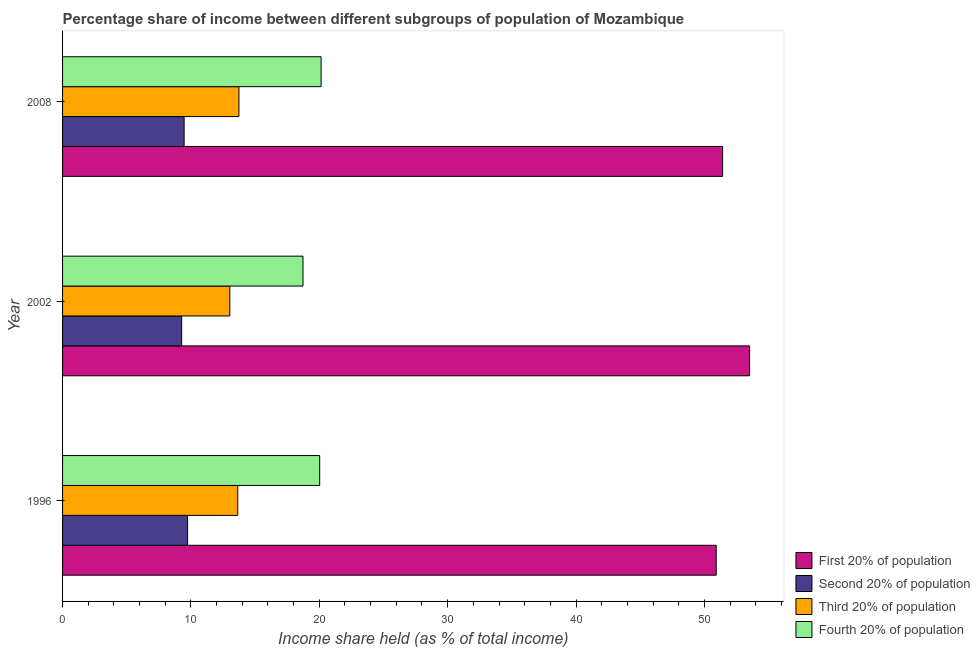How many different coloured bars are there?
Your response must be concise. 4. Are the number of bars per tick equal to the number of legend labels?
Make the answer very short. Yes. Are the number of bars on each tick of the Y-axis equal?
Offer a very short reply. Yes. How many bars are there on the 1st tick from the bottom?
Give a very brief answer. 4. What is the share of the income held by first 20% of the population in 1996?
Your answer should be very brief. 50.92. Across all years, what is the maximum share of the income held by first 20% of the population?
Offer a very short reply. 53.52. Across all years, what is the minimum share of the income held by second 20% of the population?
Ensure brevity in your answer.  9.28. In which year was the share of the income held by third 20% of the population maximum?
Give a very brief answer. 2008. What is the total share of the income held by first 20% of the population in the graph?
Your answer should be very brief. 155.86. What is the difference between the share of the income held by first 20% of the population in 2002 and that in 2008?
Ensure brevity in your answer.  2.1. What is the difference between the share of the income held by first 20% of the population in 1996 and the share of the income held by fourth 20% of the population in 2002?
Provide a short and direct response. 32.19. What is the average share of the income held by second 20% of the population per year?
Your answer should be very brief. 9.5. In the year 2002, what is the difference between the share of the income held by second 20% of the population and share of the income held by third 20% of the population?
Your response must be concise. -3.75. In how many years, is the share of the income held by second 20% of the population greater than 28 %?
Your response must be concise. 0. What is the difference between the highest and the second highest share of the income held by second 20% of the population?
Provide a short and direct response. 0.27. What is the difference between the highest and the lowest share of the income held by second 20% of the population?
Your answer should be very brief. 0.46. Is it the case that in every year, the sum of the share of the income held by fourth 20% of the population and share of the income held by second 20% of the population is greater than the sum of share of the income held by first 20% of the population and share of the income held by third 20% of the population?
Your answer should be very brief. Yes. What does the 4th bar from the top in 1996 represents?
Provide a succinct answer. First 20% of population. What does the 2nd bar from the bottom in 1996 represents?
Give a very brief answer. Second 20% of population. How many years are there in the graph?
Your response must be concise. 3. Are the values on the major ticks of X-axis written in scientific E-notation?
Ensure brevity in your answer.  No. Does the graph contain any zero values?
Provide a succinct answer. No. Does the graph contain grids?
Your response must be concise. No. What is the title of the graph?
Your answer should be compact. Percentage share of income between different subgroups of population of Mozambique. What is the label or title of the X-axis?
Keep it short and to the point. Income share held (as % of total income). What is the label or title of the Y-axis?
Your response must be concise. Year. What is the Income share held (as % of total income) in First 20% of population in 1996?
Offer a terse response. 50.92. What is the Income share held (as % of total income) in Second 20% of population in 1996?
Your answer should be very brief. 9.74. What is the Income share held (as % of total income) in Third 20% of population in 1996?
Your response must be concise. 13.65. What is the Income share held (as % of total income) of Fourth 20% of population in 1996?
Make the answer very short. 20.03. What is the Income share held (as % of total income) in First 20% of population in 2002?
Your answer should be compact. 53.52. What is the Income share held (as % of total income) of Second 20% of population in 2002?
Make the answer very short. 9.28. What is the Income share held (as % of total income) in Third 20% of population in 2002?
Your answer should be compact. 13.03. What is the Income share held (as % of total income) in Fourth 20% of population in 2002?
Offer a very short reply. 18.73. What is the Income share held (as % of total income) of First 20% of population in 2008?
Provide a succinct answer. 51.42. What is the Income share held (as % of total income) in Second 20% of population in 2008?
Give a very brief answer. 9.47. What is the Income share held (as % of total income) in Third 20% of population in 2008?
Your answer should be very brief. 13.74. What is the Income share held (as % of total income) of Fourth 20% of population in 2008?
Offer a very short reply. 20.14. Across all years, what is the maximum Income share held (as % of total income) in First 20% of population?
Offer a terse response. 53.52. Across all years, what is the maximum Income share held (as % of total income) in Second 20% of population?
Your answer should be compact. 9.74. Across all years, what is the maximum Income share held (as % of total income) of Third 20% of population?
Give a very brief answer. 13.74. Across all years, what is the maximum Income share held (as % of total income) in Fourth 20% of population?
Provide a succinct answer. 20.14. Across all years, what is the minimum Income share held (as % of total income) of First 20% of population?
Offer a terse response. 50.92. Across all years, what is the minimum Income share held (as % of total income) of Second 20% of population?
Your answer should be compact. 9.28. Across all years, what is the minimum Income share held (as % of total income) in Third 20% of population?
Give a very brief answer. 13.03. Across all years, what is the minimum Income share held (as % of total income) in Fourth 20% of population?
Make the answer very short. 18.73. What is the total Income share held (as % of total income) of First 20% of population in the graph?
Your response must be concise. 155.86. What is the total Income share held (as % of total income) in Second 20% of population in the graph?
Provide a succinct answer. 28.49. What is the total Income share held (as % of total income) in Third 20% of population in the graph?
Keep it short and to the point. 40.42. What is the total Income share held (as % of total income) in Fourth 20% of population in the graph?
Your response must be concise. 58.9. What is the difference between the Income share held (as % of total income) of Second 20% of population in 1996 and that in 2002?
Keep it short and to the point. 0.46. What is the difference between the Income share held (as % of total income) in Third 20% of population in 1996 and that in 2002?
Offer a terse response. 0.62. What is the difference between the Income share held (as % of total income) of Fourth 20% of population in 1996 and that in 2002?
Make the answer very short. 1.3. What is the difference between the Income share held (as % of total income) of First 20% of population in 1996 and that in 2008?
Provide a short and direct response. -0.5. What is the difference between the Income share held (as % of total income) in Second 20% of population in 1996 and that in 2008?
Offer a terse response. 0.27. What is the difference between the Income share held (as % of total income) of Third 20% of population in 1996 and that in 2008?
Ensure brevity in your answer.  -0.09. What is the difference between the Income share held (as % of total income) in Fourth 20% of population in 1996 and that in 2008?
Offer a very short reply. -0.11. What is the difference between the Income share held (as % of total income) in Second 20% of population in 2002 and that in 2008?
Provide a short and direct response. -0.19. What is the difference between the Income share held (as % of total income) of Third 20% of population in 2002 and that in 2008?
Your answer should be very brief. -0.71. What is the difference between the Income share held (as % of total income) in Fourth 20% of population in 2002 and that in 2008?
Give a very brief answer. -1.41. What is the difference between the Income share held (as % of total income) in First 20% of population in 1996 and the Income share held (as % of total income) in Second 20% of population in 2002?
Provide a succinct answer. 41.64. What is the difference between the Income share held (as % of total income) in First 20% of population in 1996 and the Income share held (as % of total income) in Third 20% of population in 2002?
Make the answer very short. 37.89. What is the difference between the Income share held (as % of total income) of First 20% of population in 1996 and the Income share held (as % of total income) of Fourth 20% of population in 2002?
Your answer should be very brief. 32.19. What is the difference between the Income share held (as % of total income) of Second 20% of population in 1996 and the Income share held (as % of total income) of Third 20% of population in 2002?
Offer a terse response. -3.29. What is the difference between the Income share held (as % of total income) of Second 20% of population in 1996 and the Income share held (as % of total income) of Fourth 20% of population in 2002?
Provide a succinct answer. -8.99. What is the difference between the Income share held (as % of total income) in Third 20% of population in 1996 and the Income share held (as % of total income) in Fourth 20% of population in 2002?
Give a very brief answer. -5.08. What is the difference between the Income share held (as % of total income) in First 20% of population in 1996 and the Income share held (as % of total income) in Second 20% of population in 2008?
Provide a succinct answer. 41.45. What is the difference between the Income share held (as % of total income) of First 20% of population in 1996 and the Income share held (as % of total income) of Third 20% of population in 2008?
Provide a succinct answer. 37.18. What is the difference between the Income share held (as % of total income) in First 20% of population in 1996 and the Income share held (as % of total income) in Fourth 20% of population in 2008?
Give a very brief answer. 30.78. What is the difference between the Income share held (as % of total income) in Second 20% of population in 1996 and the Income share held (as % of total income) in Third 20% of population in 2008?
Keep it short and to the point. -4. What is the difference between the Income share held (as % of total income) in Third 20% of population in 1996 and the Income share held (as % of total income) in Fourth 20% of population in 2008?
Your response must be concise. -6.49. What is the difference between the Income share held (as % of total income) in First 20% of population in 2002 and the Income share held (as % of total income) in Second 20% of population in 2008?
Keep it short and to the point. 44.05. What is the difference between the Income share held (as % of total income) in First 20% of population in 2002 and the Income share held (as % of total income) in Third 20% of population in 2008?
Provide a short and direct response. 39.78. What is the difference between the Income share held (as % of total income) in First 20% of population in 2002 and the Income share held (as % of total income) in Fourth 20% of population in 2008?
Provide a short and direct response. 33.38. What is the difference between the Income share held (as % of total income) in Second 20% of population in 2002 and the Income share held (as % of total income) in Third 20% of population in 2008?
Offer a very short reply. -4.46. What is the difference between the Income share held (as % of total income) of Second 20% of population in 2002 and the Income share held (as % of total income) of Fourth 20% of population in 2008?
Ensure brevity in your answer.  -10.86. What is the difference between the Income share held (as % of total income) in Third 20% of population in 2002 and the Income share held (as % of total income) in Fourth 20% of population in 2008?
Your response must be concise. -7.11. What is the average Income share held (as % of total income) in First 20% of population per year?
Provide a short and direct response. 51.95. What is the average Income share held (as % of total income) of Second 20% of population per year?
Your answer should be very brief. 9.5. What is the average Income share held (as % of total income) in Third 20% of population per year?
Make the answer very short. 13.47. What is the average Income share held (as % of total income) in Fourth 20% of population per year?
Your answer should be compact. 19.63. In the year 1996, what is the difference between the Income share held (as % of total income) of First 20% of population and Income share held (as % of total income) of Second 20% of population?
Make the answer very short. 41.18. In the year 1996, what is the difference between the Income share held (as % of total income) of First 20% of population and Income share held (as % of total income) of Third 20% of population?
Give a very brief answer. 37.27. In the year 1996, what is the difference between the Income share held (as % of total income) of First 20% of population and Income share held (as % of total income) of Fourth 20% of population?
Your answer should be compact. 30.89. In the year 1996, what is the difference between the Income share held (as % of total income) of Second 20% of population and Income share held (as % of total income) of Third 20% of population?
Offer a terse response. -3.91. In the year 1996, what is the difference between the Income share held (as % of total income) in Second 20% of population and Income share held (as % of total income) in Fourth 20% of population?
Give a very brief answer. -10.29. In the year 1996, what is the difference between the Income share held (as % of total income) of Third 20% of population and Income share held (as % of total income) of Fourth 20% of population?
Ensure brevity in your answer.  -6.38. In the year 2002, what is the difference between the Income share held (as % of total income) in First 20% of population and Income share held (as % of total income) in Second 20% of population?
Keep it short and to the point. 44.24. In the year 2002, what is the difference between the Income share held (as % of total income) of First 20% of population and Income share held (as % of total income) of Third 20% of population?
Your answer should be compact. 40.49. In the year 2002, what is the difference between the Income share held (as % of total income) in First 20% of population and Income share held (as % of total income) in Fourth 20% of population?
Your answer should be very brief. 34.79. In the year 2002, what is the difference between the Income share held (as % of total income) of Second 20% of population and Income share held (as % of total income) of Third 20% of population?
Keep it short and to the point. -3.75. In the year 2002, what is the difference between the Income share held (as % of total income) in Second 20% of population and Income share held (as % of total income) in Fourth 20% of population?
Provide a short and direct response. -9.45. In the year 2008, what is the difference between the Income share held (as % of total income) in First 20% of population and Income share held (as % of total income) in Second 20% of population?
Provide a short and direct response. 41.95. In the year 2008, what is the difference between the Income share held (as % of total income) of First 20% of population and Income share held (as % of total income) of Third 20% of population?
Give a very brief answer. 37.68. In the year 2008, what is the difference between the Income share held (as % of total income) of First 20% of population and Income share held (as % of total income) of Fourth 20% of population?
Keep it short and to the point. 31.28. In the year 2008, what is the difference between the Income share held (as % of total income) in Second 20% of population and Income share held (as % of total income) in Third 20% of population?
Provide a succinct answer. -4.27. In the year 2008, what is the difference between the Income share held (as % of total income) of Second 20% of population and Income share held (as % of total income) of Fourth 20% of population?
Provide a succinct answer. -10.67. In the year 2008, what is the difference between the Income share held (as % of total income) of Third 20% of population and Income share held (as % of total income) of Fourth 20% of population?
Provide a short and direct response. -6.4. What is the ratio of the Income share held (as % of total income) of First 20% of population in 1996 to that in 2002?
Your answer should be very brief. 0.95. What is the ratio of the Income share held (as % of total income) of Second 20% of population in 1996 to that in 2002?
Give a very brief answer. 1.05. What is the ratio of the Income share held (as % of total income) in Third 20% of population in 1996 to that in 2002?
Provide a short and direct response. 1.05. What is the ratio of the Income share held (as % of total income) of Fourth 20% of population in 1996 to that in 2002?
Offer a terse response. 1.07. What is the ratio of the Income share held (as % of total income) of First 20% of population in 1996 to that in 2008?
Provide a short and direct response. 0.99. What is the ratio of the Income share held (as % of total income) of Second 20% of population in 1996 to that in 2008?
Make the answer very short. 1.03. What is the ratio of the Income share held (as % of total income) of First 20% of population in 2002 to that in 2008?
Provide a succinct answer. 1.04. What is the ratio of the Income share held (as % of total income) in Second 20% of population in 2002 to that in 2008?
Your response must be concise. 0.98. What is the ratio of the Income share held (as % of total income) of Third 20% of population in 2002 to that in 2008?
Give a very brief answer. 0.95. What is the ratio of the Income share held (as % of total income) of Fourth 20% of population in 2002 to that in 2008?
Provide a short and direct response. 0.93. What is the difference between the highest and the second highest Income share held (as % of total income) in Second 20% of population?
Provide a succinct answer. 0.27. What is the difference between the highest and the second highest Income share held (as % of total income) of Third 20% of population?
Your answer should be very brief. 0.09. What is the difference between the highest and the second highest Income share held (as % of total income) in Fourth 20% of population?
Ensure brevity in your answer.  0.11. What is the difference between the highest and the lowest Income share held (as % of total income) in Second 20% of population?
Offer a terse response. 0.46. What is the difference between the highest and the lowest Income share held (as % of total income) in Third 20% of population?
Your answer should be compact. 0.71. What is the difference between the highest and the lowest Income share held (as % of total income) in Fourth 20% of population?
Your answer should be very brief. 1.41. 